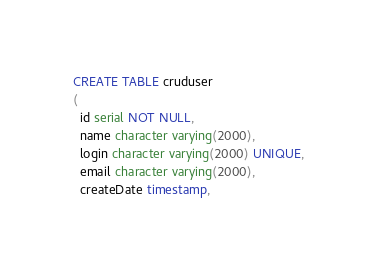Convert code to text. <code><loc_0><loc_0><loc_500><loc_500><_SQL_>CREATE TABLE cruduser
(
  id serial NOT NULL,
  name character varying(2000),
  login character varying(2000) UNIQUE,
  email character varying(2000),
  createDate timestamp,</code> 